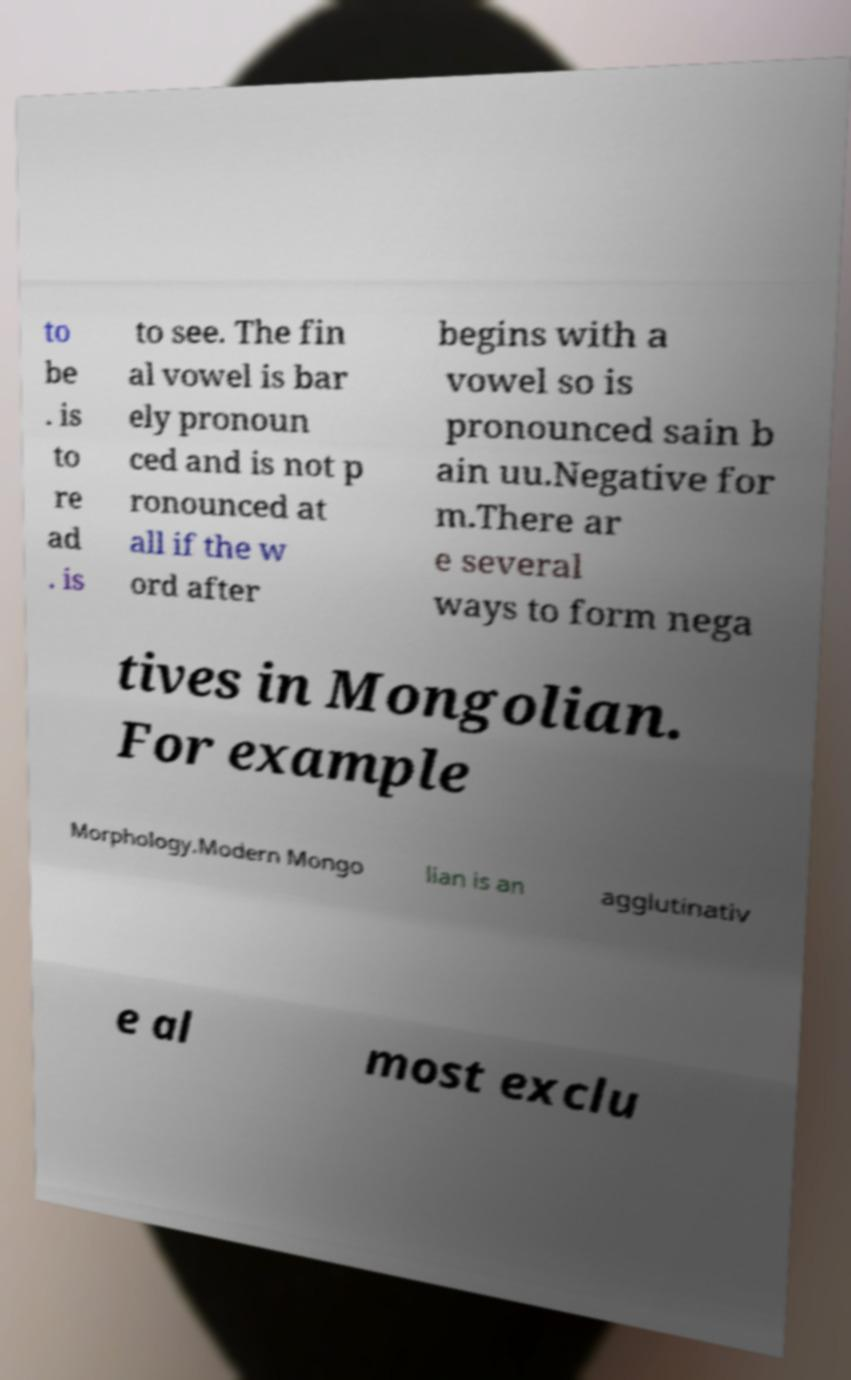I need the written content from this picture converted into text. Can you do that? to be . is to re ad . is to see. The fin al vowel is bar ely pronoun ced and is not p ronounced at all if the w ord after begins with a vowel so is pronounced sain b ain uu.Negative for m.There ar e several ways to form nega tives in Mongolian. For example Morphology.Modern Mongo lian is an agglutinativ e al most exclu 